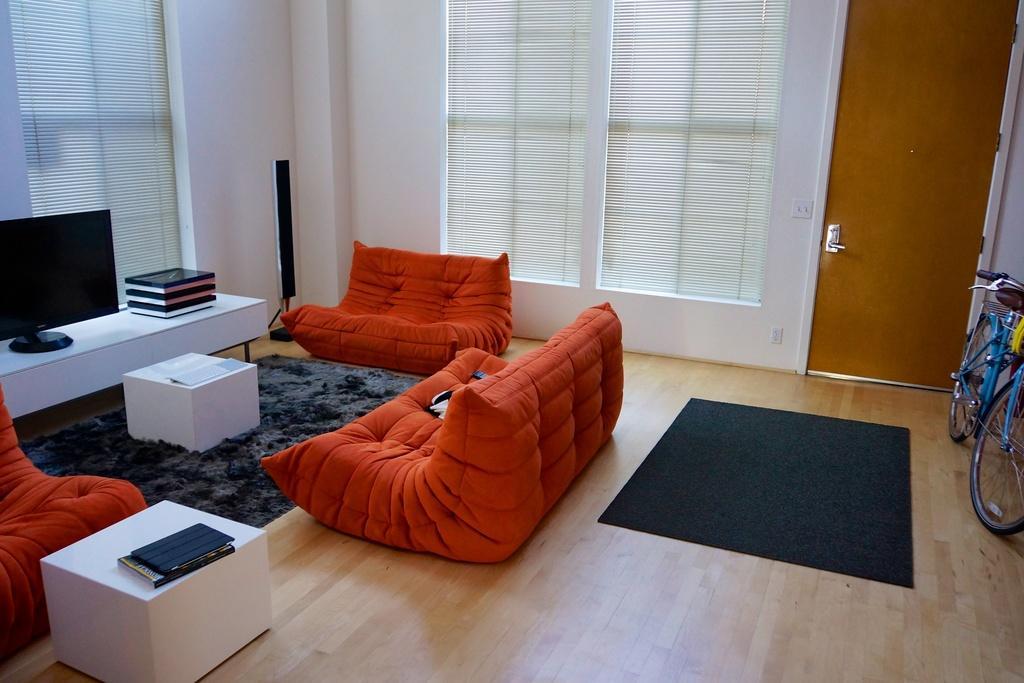Could you give a brief overview of what you see in this image? A picture of a room. This are couches in orange color. In-front of this cough there is a table. On a table there is a paper. On this white table there are boards and television. This are windows with curtain. Floor with carpets. On this table there are things. Beside this door there is a bicycle. 